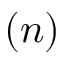<formula> <loc_0><loc_0><loc_500><loc_500>( n )</formula> 